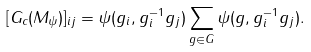Convert formula to latex. <formula><loc_0><loc_0><loc_500><loc_500>[ G _ { c } ( M _ { \psi } ) ] _ { i j } = \psi ( g _ { i } , g _ { i } ^ { - 1 } g _ { j } ) \sum _ { g \in G } \psi ( g , g _ { i } ^ { - 1 } g _ { j } ) .</formula> 